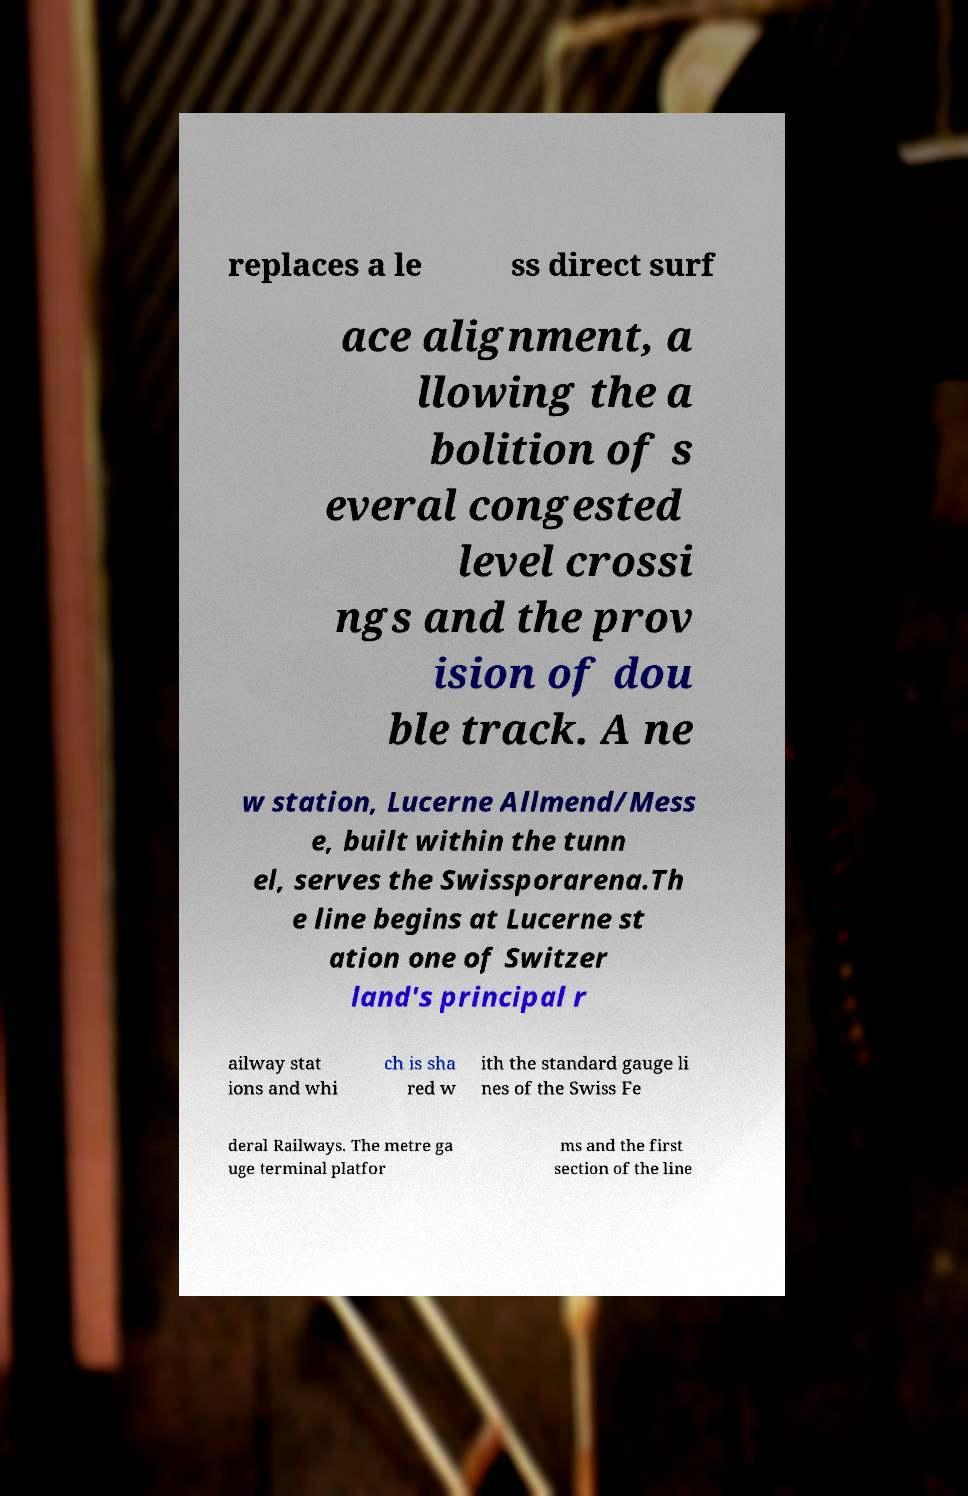For documentation purposes, I need the text within this image transcribed. Could you provide that? replaces a le ss direct surf ace alignment, a llowing the a bolition of s everal congested level crossi ngs and the prov ision of dou ble track. A ne w station, Lucerne Allmend/Mess e, built within the tunn el, serves the Swissporarena.Th e line begins at Lucerne st ation one of Switzer land's principal r ailway stat ions and whi ch is sha red w ith the standard gauge li nes of the Swiss Fe deral Railways. The metre ga uge terminal platfor ms and the first section of the line 